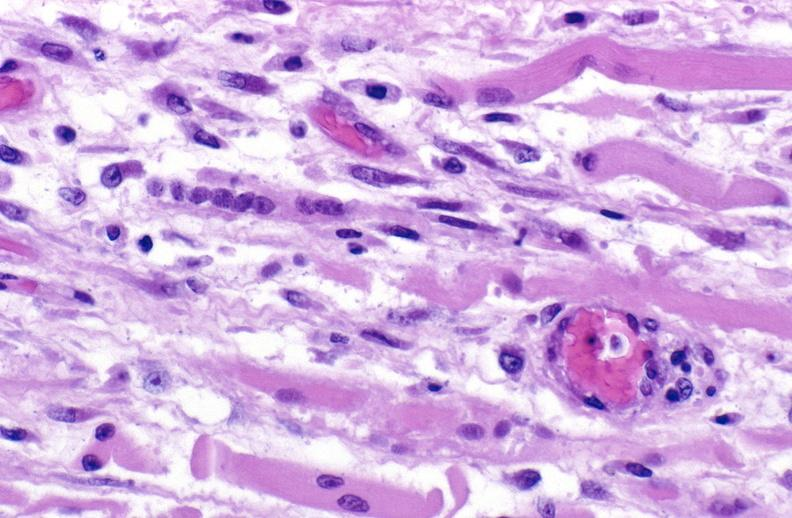s this image shows of smooth muscle cell with lipid in sarcoplasm and lipid present?
Answer the question using a single word or phrase. No 